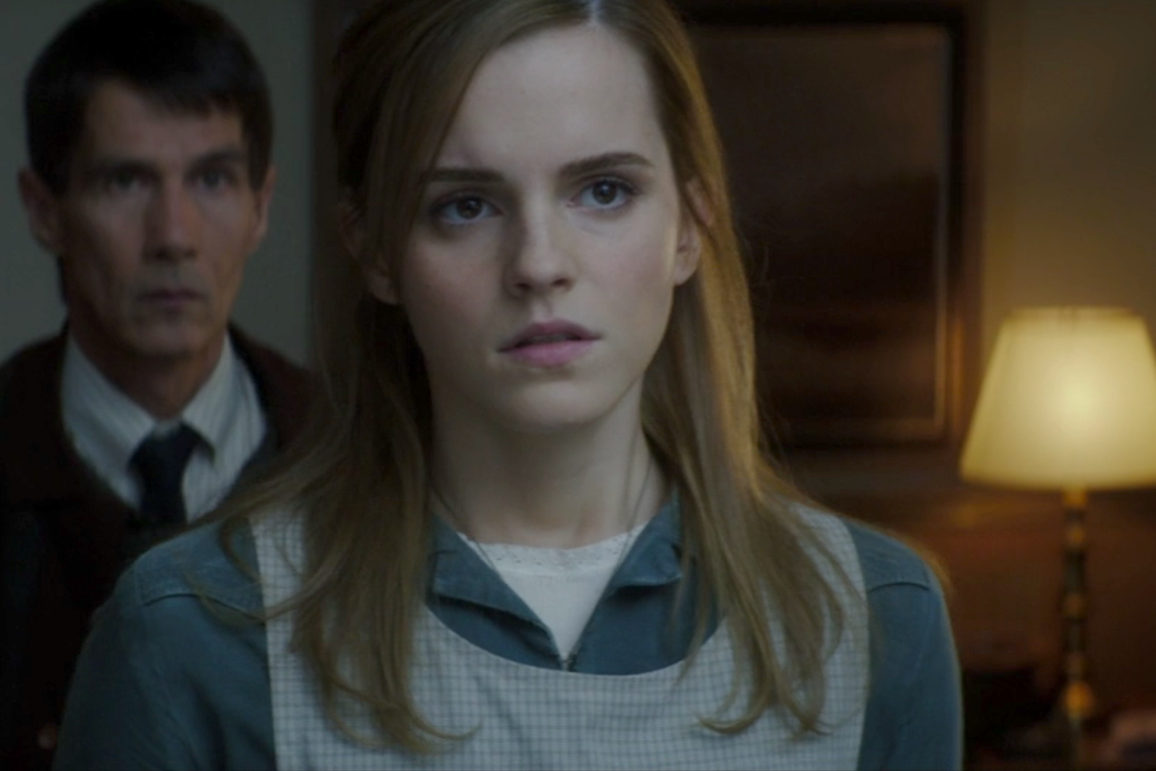Imagine this image is taken from a mystery novel. Describe the situation leading up to this moment. In a fictional mystery novel, this moment captures the intense aftermath of a significant revelation. The woman in the foreground, who is an investigative journalist, has just uncovered a key piece of evidence linking a respected, yet enigmatic town figure (the man in the background) to a series of bizarre incidents. Her expression reflects the weight of this discovery as she grapples with the implications it could have on the community and her own safety. The man, sensing her discovery, stands behind her in quiet confrontation, his own demeanor equally intense, knowing that his secrets are at risk of being exposed. The warm yet dimly lit room adds to the tension, with the lone lamp casting a spotlight on this critical confrontation. 